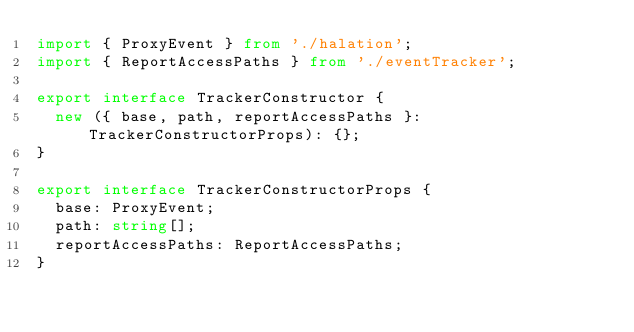Convert code to text. <code><loc_0><loc_0><loc_500><loc_500><_TypeScript_>import { ProxyEvent } from './halation';
import { ReportAccessPaths } from './eventTracker';

export interface TrackerConstructor {
  new ({ base, path, reportAccessPaths }: TrackerConstructorProps): {};
}

export interface TrackerConstructorProps {
  base: ProxyEvent;
  path: string[];
  reportAccessPaths: ReportAccessPaths;
}
</code> 